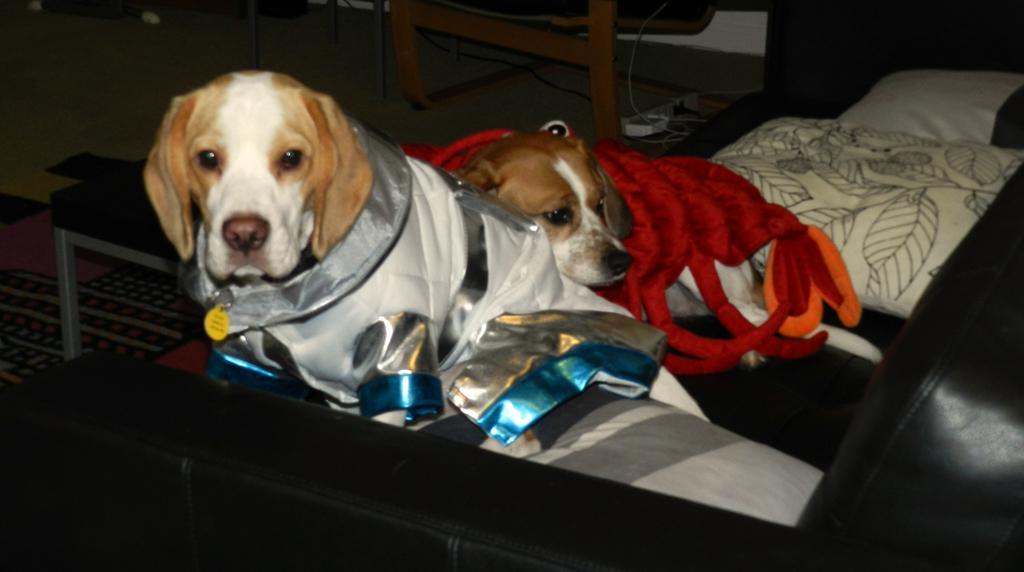In one or two sentences, can you explain what this image depicts? This image consists of two dogs. At the bottom, there is a sofa. In the front, we can see a table made up of wood. At the bottom, there is a floor. 